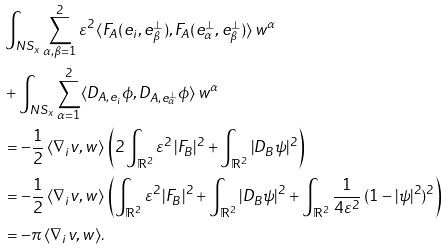Convert formula to latex. <formula><loc_0><loc_0><loc_500><loc_500>& \int _ { N S _ { x } } \sum _ { \alpha , \beta = 1 } ^ { 2 } \varepsilon ^ { 2 } \, \langle F _ { A } ( e _ { i } , e _ { \beta } ^ { \perp } ) , F _ { A } ( e _ { \alpha } ^ { \perp } , e _ { \beta } ^ { \perp } ) \rangle \, w ^ { \alpha } \\ & + \int _ { N S _ { x } } \sum _ { \alpha = 1 } ^ { 2 } \langle D _ { A , e _ { i } } \phi , D _ { A , e _ { \alpha } ^ { \perp } } \phi \rangle \, w ^ { \alpha } \\ & = - \frac { 1 } { 2 } \, \langle \nabla _ { i } v , w \rangle \, \left ( 2 \int _ { \mathbb { R } ^ { 2 } } \varepsilon ^ { 2 } \, | F _ { B } | ^ { 2 } + \int _ { \mathbb { R } ^ { 2 } } | D _ { B } \psi | ^ { 2 } \right ) \\ & = - \frac { 1 } { 2 } \, \langle \nabla _ { i } v , w \rangle \, \left ( \int _ { \mathbb { R } ^ { 2 } } \varepsilon ^ { 2 } \, | F _ { B } | ^ { 2 } + \int _ { \mathbb { R } ^ { 2 } } | D _ { B } \psi | ^ { 2 } + \int _ { \mathbb { R } ^ { 2 } } \frac { 1 } { 4 \varepsilon ^ { 2 } } \, ( 1 - | \psi | ^ { 2 } ) ^ { 2 } \right ) \\ & = - \pi \, \langle \nabla _ { i } v , w \rangle .</formula> 